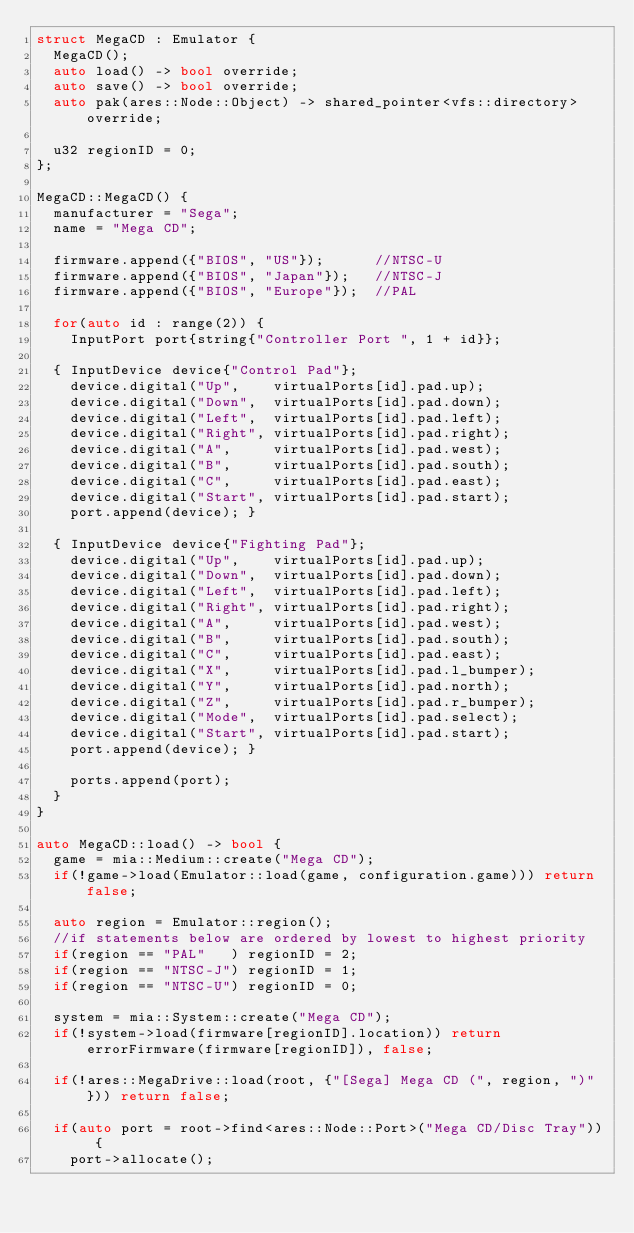<code> <loc_0><loc_0><loc_500><loc_500><_C++_>struct MegaCD : Emulator {
  MegaCD();
  auto load() -> bool override;
  auto save() -> bool override;
  auto pak(ares::Node::Object) -> shared_pointer<vfs::directory> override;

  u32 regionID = 0;
};

MegaCD::MegaCD() {
  manufacturer = "Sega";
  name = "Mega CD";

  firmware.append({"BIOS", "US"});      //NTSC-U
  firmware.append({"BIOS", "Japan"});   //NTSC-J
  firmware.append({"BIOS", "Europe"});  //PAL

  for(auto id : range(2)) {
    InputPort port{string{"Controller Port ", 1 + id}};

  { InputDevice device{"Control Pad"};
    device.digital("Up",    virtualPorts[id].pad.up);
    device.digital("Down",  virtualPorts[id].pad.down);
    device.digital("Left",  virtualPorts[id].pad.left);
    device.digital("Right", virtualPorts[id].pad.right);
    device.digital("A",     virtualPorts[id].pad.west);
    device.digital("B",     virtualPorts[id].pad.south);
    device.digital("C",     virtualPorts[id].pad.east);
    device.digital("Start", virtualPorts[id].pad.start);
    port.append(device); }

  { InputDevice device{"Fighting Pad"};
    device.digital("Up",    virtualPorts[id].pad.up);
    device.digital("Down",  virtualPorts[id].pad.down);
    device.digital("Left",  virtualPorts[id].pad.left);
    device.digital("Right", virtualPorts[id].pad.right);
    device.digital("A",     virtualPorts[id].pad.west);
    device.digital("B",     virtualPorts[id].pad.south);
    device.digital("C",     virtualPorts[id].pad.east);
    device.digital("X",     virtualPorts[id].pad.l_bumper);
    device.digital("Y",     virtualPorts[id].pad.north);
    device.digital("Z",     virtualPorts[id].pad.r_bumper);
    device.digital("Mode",  virtualPorts[id].pad.select);
    device.digital("Start", virtualPorts[id].pad.start);
    port.append(device); }

    ports.append(port);
  }
}

auto MegaCD::load() -> bool {
  game = mia::Medium::create("Mega CD");
  if(!game->load(Emulator::load(game, configuration.game))) return false;

  auto region = Emulator::region();
  //if statements below are ordered by lowest to highest priority
  if(region == "PAL"   ) regionID = 2;
  if(region == "NTSC-J") regionID = 1;
  if(region == "NTSC-U") regionID = 0;

  system = mia::System::create("Mega CD");
  if(!system->load(firmware[regionID].location)) return errorFirmware(firmware[regionID]), false;

  if(!ares::MegaDrive::load(root, {"[Sega] Mega CD (", region, ")"})) return false;

  if(auto port = root->find<ares::Node::Port>("Mega CD/Disc Tray")) {
    port->allocate();</code> 